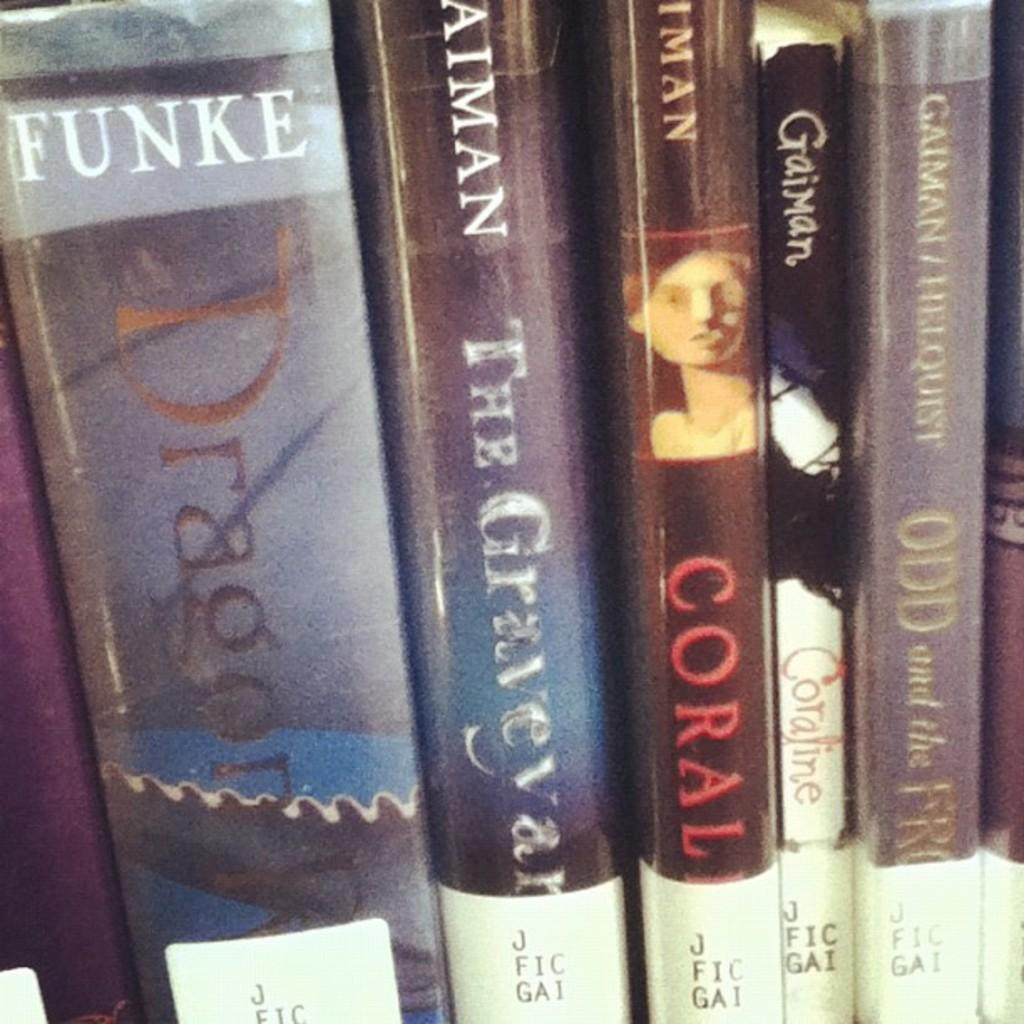<image>
Summarize the visual content of the image. A book by Funke titled Dragon sits on a shelf next to a book called The Graveyard 